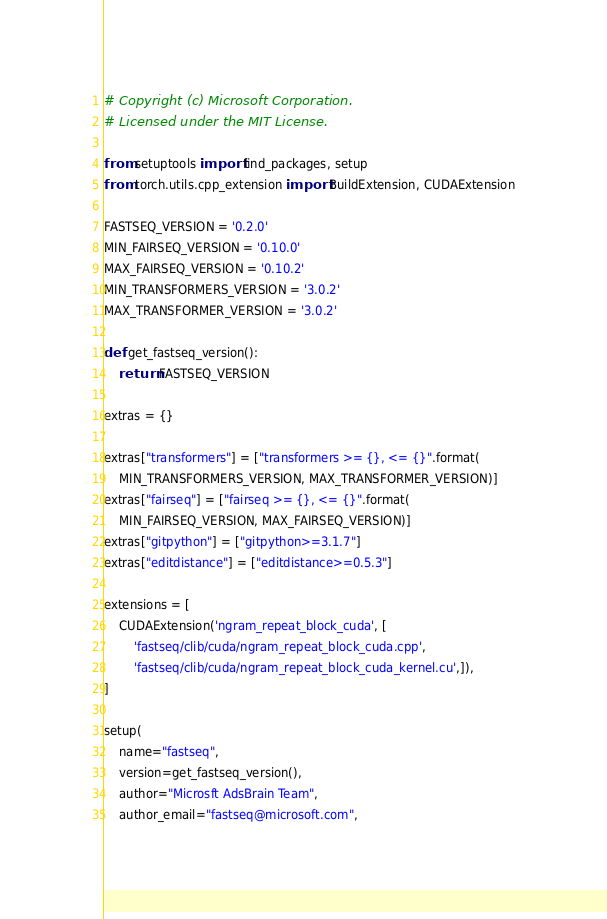Convert code to text. <code><loc_0><loc_0><loc_500><loc_500><_Python_># Copyright (c) Microsoft Corporation.
# Licensed under the MIT License.

from setuptools import find_packages, setup
from torch.utils.cpp_extension import BuildExtension, CUDAExtension

FASTSEQ_VERSION = '0.2.0'
MIN_FAIRSEQ_VERSION = '0.10.0'
MAX_FAIRSEQ_VERSION = '0.10.2'
MIN_TRANSFORMERS_VERSION = '3.0.2'
MAX_TRANSFORMER_VERSION = '3.0.2'

def get_fastseq_version():
    return FASTSEQ_VERSION

extras = {}

extras["transformers"] = ["transformers >= {}, <= {}".format(
    MIN_TRANSFORMERS_VERSION, MAX_TRANSFORMER_VERSION)]
extras["fairseq"] = ["fairseq >= {}, <= {}".format(
    MIN_FAIRSEQ_VERSION, MAX_FAIRSEQ_VERSION)]
extras["gitpython"] = ["gitpython>=3.1.7"]
extras["editdistance"] = ["editdistance>=0.5.3"]

extensions = [
    CUDAExtension('ngram_repeat_block_cuda', [
        'fastseq/clib/cuda/ngram_repeat_block_cuda.cpp',
        'fastseq/clib/cuda/ngram_repeat_block_cuda_kernel.cu',]),
]

setup(
    name="fastseq",
    version=get_fastseq_version(),
    author="Microsft AdsBrain Team",
    author_email="fastseq@microsoft.com",</code> 